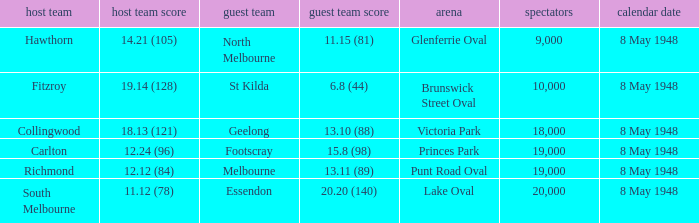Which away team played the home team when they scored 14.21 (105)? North Melbourne. I'm looking to parse the entire table for insights. Could you assist me with that? {'header': ['host team', 'host team score', 'guest team', 'guest team score', 'arena', 'spectators', 'calendar date'], 'rows': [['Hawthorn', '14.21 (105)', 'North Melbourne', '11.15 (81)', 'Glenferrie Oval', '9,000', '8 May 1948'], ['Fitzroy', '19.14 (128)', 'St Kilda', '6.8 (44)', 'Brunswick Street Oval', '10,000', '8 May 1948'], ['Collingwood', '18.13 (121)', 'Geelong', '13.10 (88)', 'Victoria Park', '18,000', '8 May 1948'], ['Carlton', '12.24 (96)', 'Footscray', '15.8 (98)', 'Princes Park', '19,000', '8 May 1948'], ['Richmond', '12.12 (84)', 'Melbourne', '13.11 (89)', 'Punt Road Oval', '19,000', '8 May 1948'], ['South Melbourne', '11.12 (78)', 'Essendon', '20.20 (140)', 'Lake Oval', '20,000', '8 May 1948']]} 